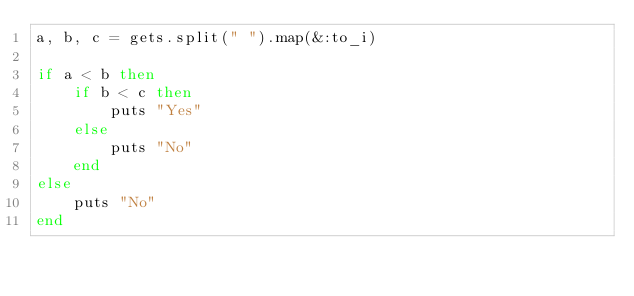Convert code to text. <code><loc_0><loc_0><loc_500><loc_500><_Ruby_>a, b, c = gets.split(" ").map(&:to_i)

if a < b then
    if b < c then
        puts "Yes"
    else
        puts "No"
    end
else
    puts "No"
end</code> 